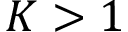<formula> <loc_0><loc_0><loc_500><loc_500>K > 1</formula> 